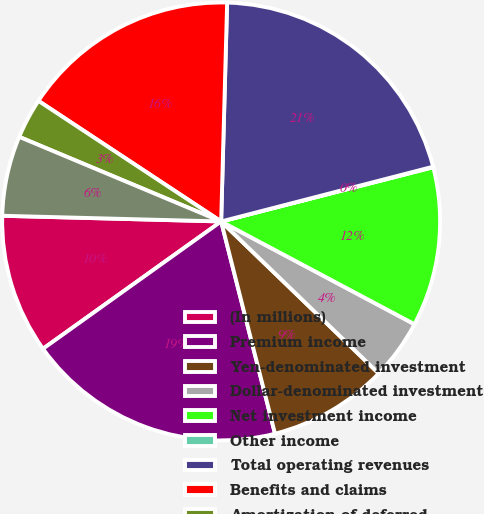Convert chart to OTSL. <chart><loc_0><loc_0><loc_500><loc_500><pie_chart><fcel>(In millions)<fcel>Premium income<fcel>Yen-denominated investment<fcel>Dollar-denominated investment<fcel>Net investment income<fcel>Other income<fcel>Total operating revenues<fcel>Benefits and claims<fcel>Amortization of deferred<fcel>Insurance commissions<nl><fcel>10.29%<fcel>19.08%<fcel>8.83%<fcel>4.44%<fcel>11.76%<fcel>0.04%<fcel>20.54%<fcel>16.15%<fcel>2.97%<fcel>5.9%<nl></chart> 